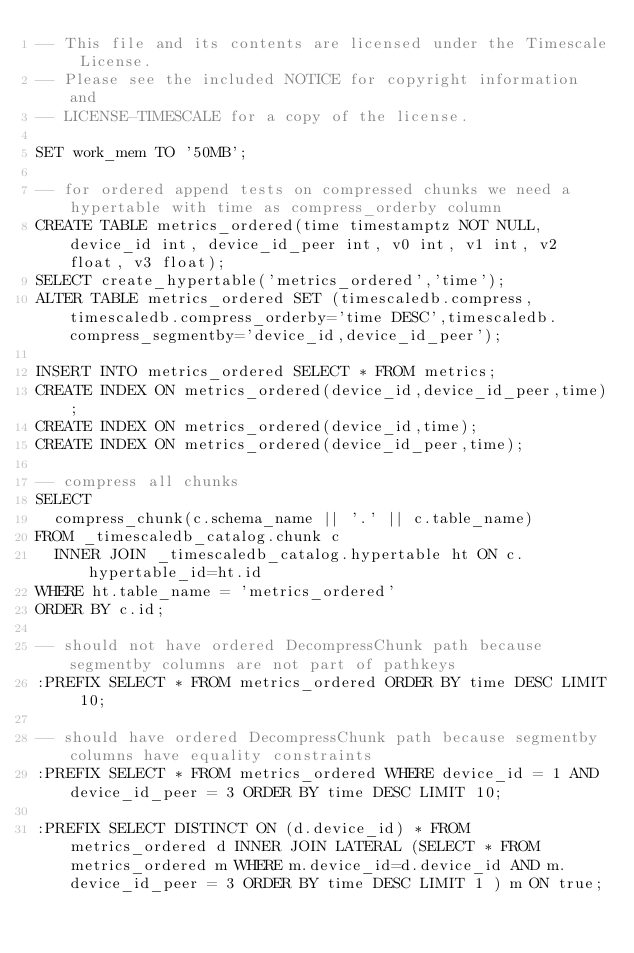<code> <loc_0><loc_0><loc_500><loc_500><_SQL_>-- This file and its contents are licensed under the Timescale License.
-- Please see the included NOTICE for copyright information and
-- LICENSE-TIMESCALE for a copy of the license.

SET work_mem TO '50MB';

-- for ordered append tests on compressed chunks we need a hypertable with time as compress_orderby column
CREATE TABLE metrics_ordered(time timestamptz NOT NULL, device_id int, device_id_peer int, v0 int, v1 int, v2 float, v3 float);
SELECT create_hypertable('metrics_ordered','time');
ALTER TABLE metrics_ordered SET (timescaledb.compress, timescaledb.compress_orderby='time DESC',timescaledb.compress_segmentby='device_id,device_id_peer');

INSERT INTO metrics_ordered SELECT * FROM metrics;
CREATE INDEX ON metrics_ordered(device_id,device_id_peer,time);
CREATE INDEX ON metrics_ordered(device_id,time);
CREATE INDEX ON metrics_ordered(device_id_peer,time);

-- compress all chunks
SELECT
  compress_chunk(c.schema_name || '.' || c.table_name)
FROM _timescaledb_catalog.chunk c
  INNER JOIN _timescaledb_catalog.hypertable ht ON c.hypertable_id=ht.id
WHERE ht.table_name = 'metrics_ordered'
ORDER BY c.id;

-- should not have ordered DecompressChunk path because segmentby columns are not part of pathkeys
:PREFIX SELECT * FROM metrics_ordered ORDER BY time DESC LIMIT 10;

-- should have ordered DecompressChunk path because segmentby columns have equality constraints
:PREFIX SELECT * FROM metrics_ordered WHERE device_id = 1 AND device_id_peer = 3 ORDER BY time DESC LIMIT 10;

:PREFIX SELECT DISTINCT ON (d.device_id) * FROM metrics_ordered d INNER JOIN LATERAL (SELECT * FROM metrics_ordered m WHERE m.device_id=d.device_id AND m.device_id_peer = 3 ORDER BY time DESC LIMIT 1 ) m ON true;
</code> 